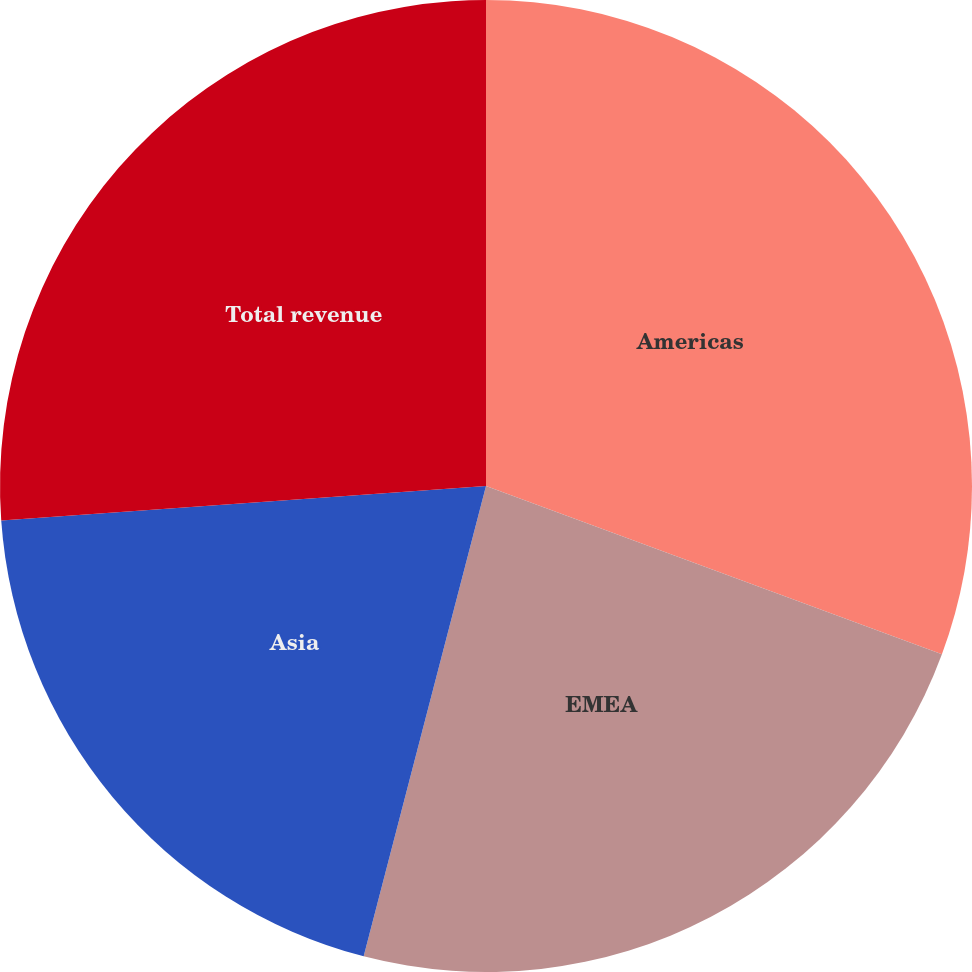Convert chart. <chart><loc_0><loc_0><loc_500><loc_500><pie_chart><fcel>Americas<fcel>EMEA<fcel>Asia<fcel>Total revenue<nl><fcel>30.63%<fcel>23.42%<fcel>19.82%<fcel>26.13%<nl></chart> 